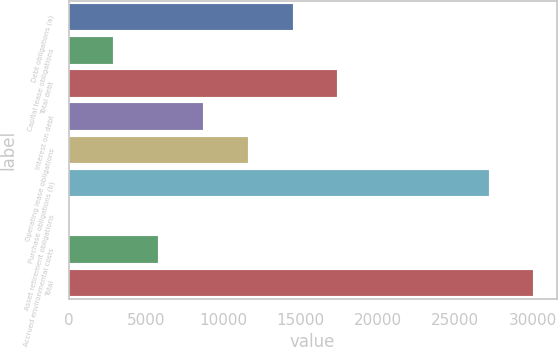Convert chart to OTSL. <chart><loc_0><loc_0><loc_500><loc_500><bar_chart><fcel>Debt obligations (a)<fcel>Capital lease obligations<fcel>Total debt<fcel>Interest on debt<fcel>Operating lease obligations<fcel>Purchase obligations (b)<fcel>Asset retirement obligations<fcel>Accrued environmental costs<fcel>Total<nl><fcel>14481.5<fcel>2902.7<fcel>17376.2<fcel>8692.1<fcel>11586.8<fcel>27161<fcel>8<fcel>5797.4<fcel>30055.7<nl></chart> 